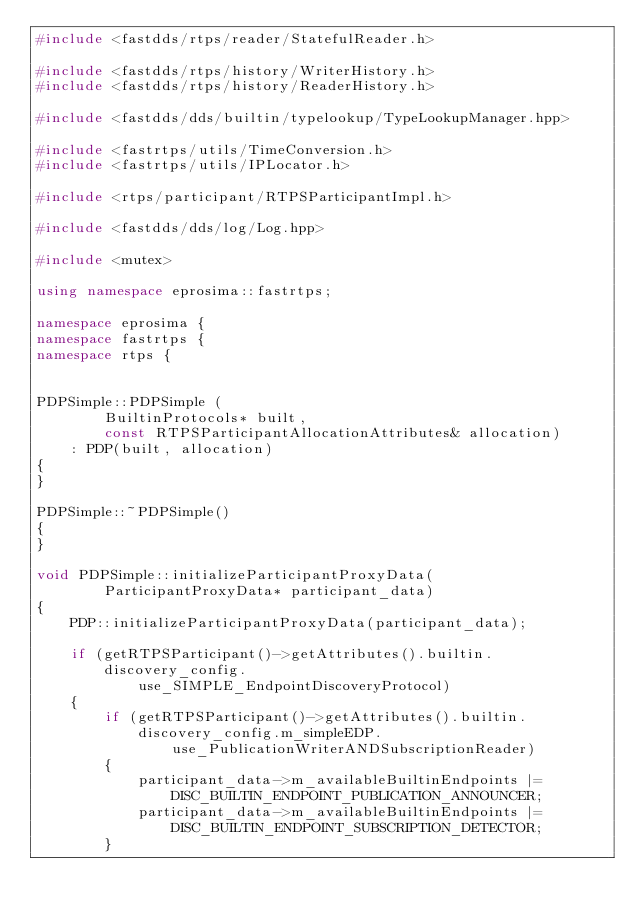<code> <loc_0><loc_0><loc_500><loc_500><_C++_>#include <fastdds/rtps/reader/StatefulReader.h>

#include <fastdds/rtps/history/WriterHistory.h>
#include <fastdds/rtps/history/ReaderHistory.h>

#include <fastdds/dds/builtin/typelookup/TypeLookupManager.hpp>

#include <fastrtps/utils/TimeConversion.h>
#include <fastrtps/utils/IPLocator.h>

#include <rtps/participant/RTPSParticipantImpl.h>

#include <fastdds/dds/log/Log.hpp>

#include <mutex>

using namespace eprosima::fastrtps;

namespace eprosima {
namespace fastrtps {
namespace rtps {


PDPSimple::PDPSimple (
        BuiltinProtocols* built,
        const RTPSParticipantAllocationAttributes& allocation)
    : PDP(built, allocation)
{
}

PDPSimple::~PDPSimple()
{
}

void PDPSimple::initializeParticipantProxyData(
        ParticipantProxyData* participant_data)
{
    PDP::initializeParticipantProxyData(participant_data);

    if (getRTPSParticipant()->getAttributes().builtin.discovery_config.
            use_SIMPLE_EndpointDiscoveryProtocol)
    {
        if (getRTPSParticipant()->getAttributes().builtin.discovery_config.m_simpleEDP.
                use_PublicationWriterANDSubscriptionReader)
        {
            participant_data->m_availableBuiltinEndpoints |= DISC_BUILTIN_ENDPOINT_PUBLICATION_ANNOUNCER;
            participant_data->m_availableBuiltinEndpoints |= DISC_BUILTIN_ENDPOINT_SUBSCRIPTION_DETECTOR;
        }
</code> 